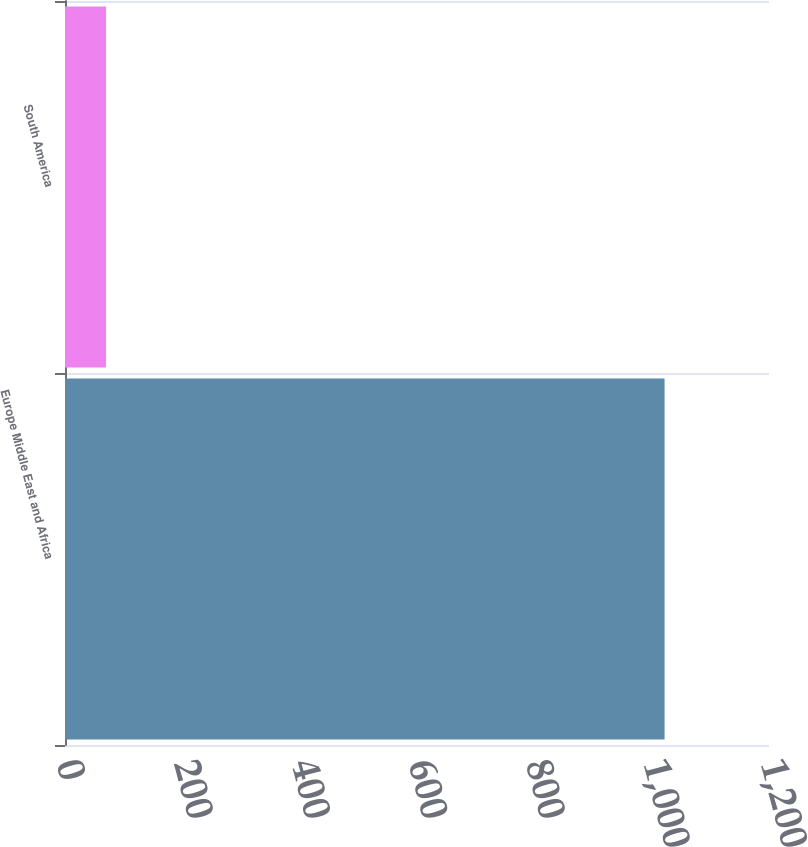Convert chart. <chart><loc_0><loc_0><loc_500><loc_500><bar_chart><fcel>Europe Middle East and Africa<fcel>South America<nl><fcel>1022<fcel>70<nl></chart> 